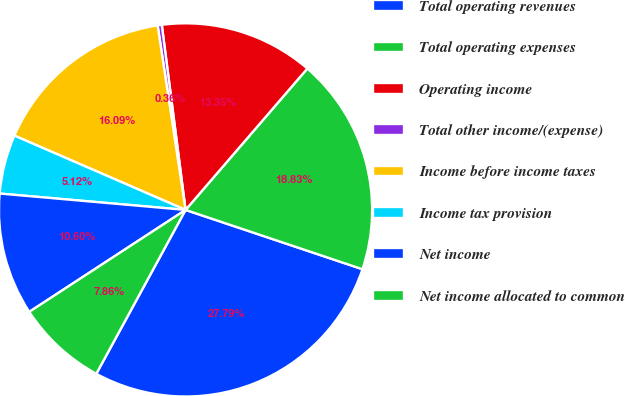<chart> <loc_0><loc_0><loc_500><loc_500><pie_chart><fcel>Total operating revenues<fcel>Total operating expenses<fcel>Operating income<fcel>Total other income/(expense)<fcel>Income before income taxes<fcel>Income tax provision<fcel>Net income<fcel>Net income allocated to common<nl><fcel>27.79%<fcel>18.83%<fcel>13.35%<fcel>0.36%<fcel>16.09%<fcel>5.12%<fcel>10.6%<fcel>7.86%<nl></chart> 